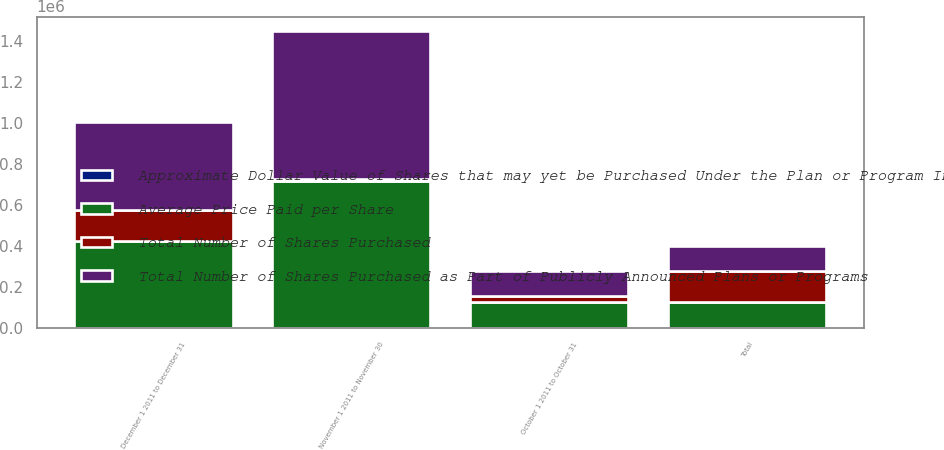Convert chart to OTSL. <chart><loc_0><loc_0><loc_500><loc_500><stacked_bar_chart><ecel><fcel>October 1 2011 to October 31<fcel>November 1 2011 to November 30<fcel>December 1 2011 to December 31<fcel>Total<nl><fcel>Average Price Paid per Share<fcel>125621<fcel>717639<fcel>427355<fcel>125621<nl><fcel>Approximate Dollar Value of Shares that may yet be Purchased Under the Plan or Program In Thousands<fcel>25.69<fcel>24.98<fcel>24.45<fcel>24.87<nl><fcel>Total Number of Shares Purchased as Part of Publicly Announced Plans or Programs<fcel>125621<fcel>717639<fcel>427355<fcel>125621<nl><fcel>Total Number of Shares Purchased<fcel>29421<fcel>11494<fcel>151046<fcel>151046<nl></chart> 